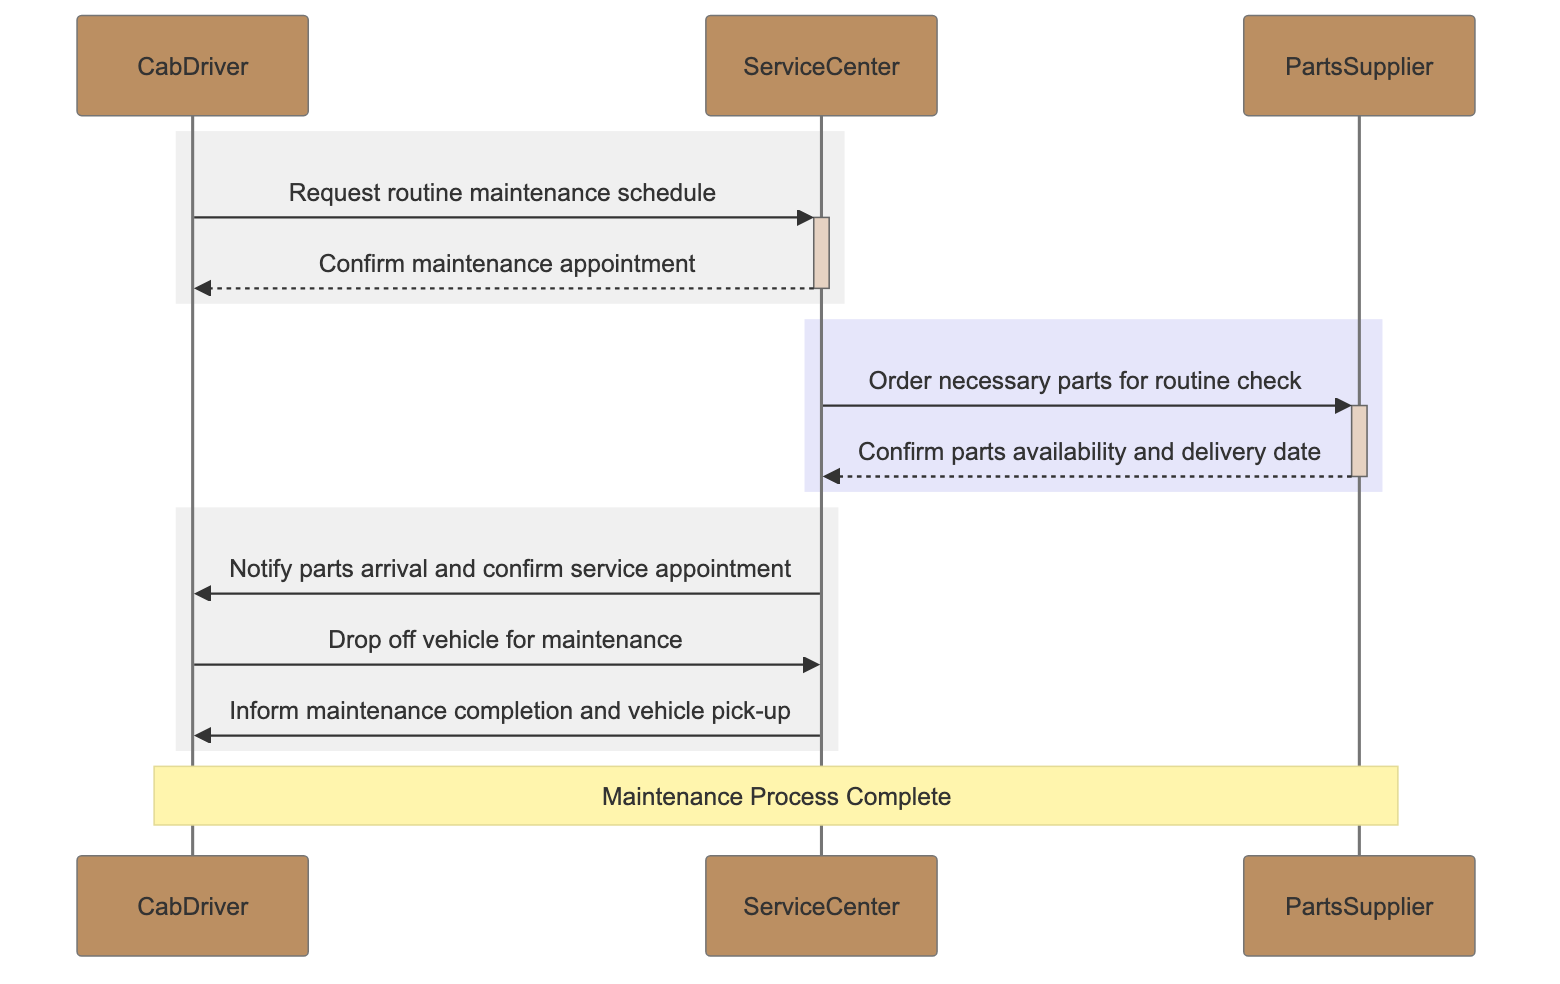What is the first message sent in the sequence? The first message is from the CabDriver to the ServiceCenter requesting a routine maintenance schedule. This is identified as the first interaction in the diagram.
Answer: Request routine maintenance schedule How many participants are involved in the sequence? There are three participants involved: CabDriver, ServiceCenter, and PartsSupplier. This can be counted from the list of participants.
Answer: 3 Which participant confirms the maintenance appointment? The ServiceCenter confirms the maintenance appointment to the CabDriver. This is indicated as the response to the first message in the diagram.
Answer: ServiceCenter What is the last message indicating in the sequence? The last message indicates that the ServiceCenter informs the CabDriver that maintenance is complete and provides details for vehicle pick-up. This concludes the maintenance process.
Answer: Inform maintenance completion and vehicle pick-up Who orders parts for the routine check? The ServiceCenter is the one that places the order for necessary parts with the PartsSupplier. This is shown in the part of the diagram that discusses ordering parts.
Answer: ServiceCenter Which participant is responsible for confirming parts availability? The PartsSupplier is responsible for confirming the availability and delivery date of the parts back to the ServiceCenter. That step is shown in the flow from PartsSupplier to ServiceCenter.
Answer: PartsSupplier What type of parts does the ServiceCenter order? The ServiceCenter orders necessary parts for the routine check, as specified in the message exchanged with the PartsSupplier.
Answer: Necessary parts How does the CabDriver drop off the vehicle? The CabDriver drops off the vehicle for maintenance by sending a message to the ServiceCenter, as shown in the procedure outlined in the diagram.
Answer: Drop off vehicle for maintenance How is the maintenance process summarized? The maintenance process is summarized in a note indicating that it is complete, positioned over the CabDriver and PartsSupplier in the diagram.
Answer: Maintenance Process Complete 